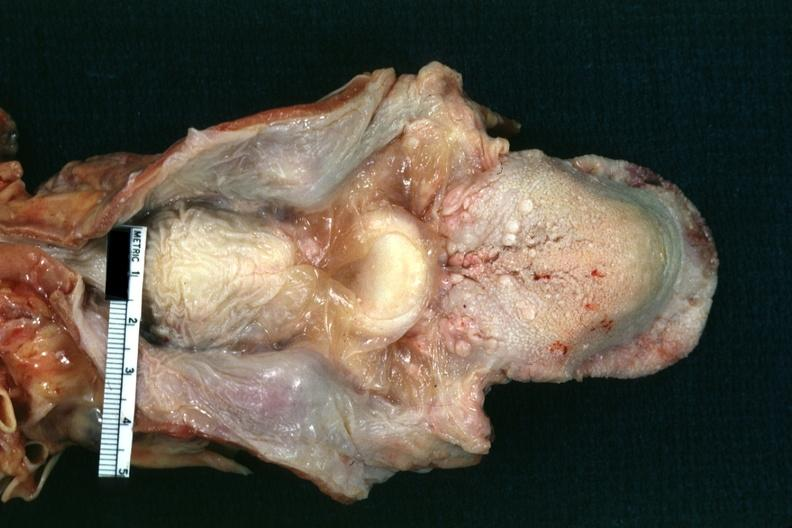where is this?
Answer the question using a single word or phrase. Oral 